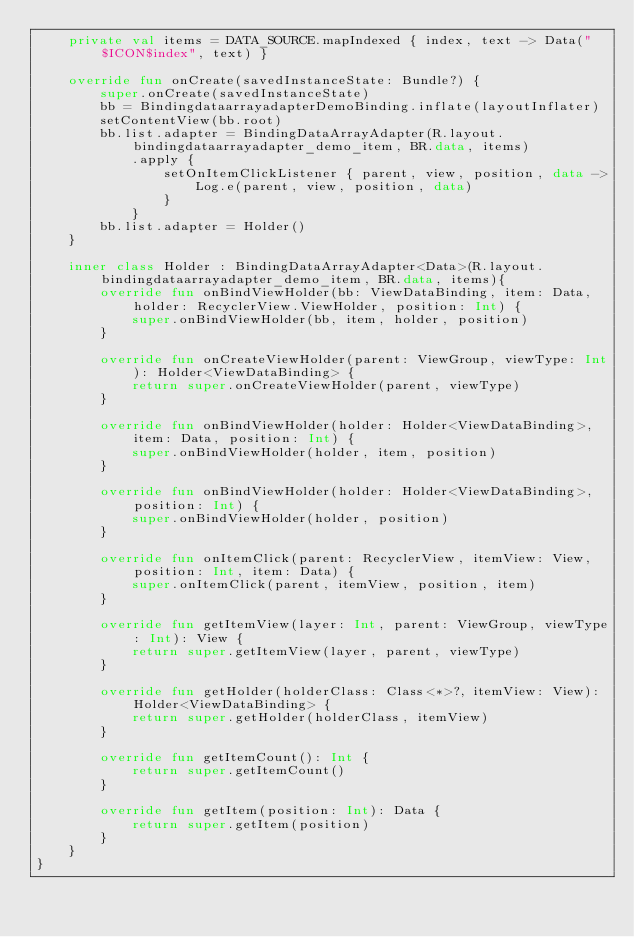<code> <loc_0><loc_0><loc_500><loc_500><_Kotlin_>    private val items = DATA_SOURCE.mapIndexed { index, text -> Data("$ICON$index", text) }

    override fun onCreate(savedInstanceState: Bundle?) {
        super.onCreate(savedInstanceState)
        bb = BindingdataarrayadapterDemoBinding.inflate(layoutInflater)
        setContentView(bb.root)
        bb.list.adapter = BindingDataArrayAdapter(R.layout.bindingdataarrayadapter_demo_item, BR.data, items)
            .apply {
                setOnItemClickListener { parent, view, position, data ->
                    Log.e(parent, view, position, data)
                }
            }
        bb.list.adapter = Holder()
    }

    inner class Holder : BindingDataArrayAdapter<Data>(R.layout.bindingdataarrayadapter_demo_item, BR.data, items){
        override fun onBindViewHolder(bb: ViewDataBinding, item: Data, holder: RecyclerView.ViewHolder, position: Int) {
            super.onBindViewHolder(bb, item, holder, position)
        }

        override fun onCreateViewHolder(parent: ViewGroup, viewType: Int): Holder<ViewDataBinding> {
            return super.onCreateViewHolder(parent, viewType)
        }

        override fun onBindViewHolder(holder: Holder<ViewDataBinding>, item: Data, position: Int) {
            super.onBindViewHolder(holder, item, position)
        }

        override fun onBindViewHolder(holder: Holder<ViewDataBinding>, position: Int) {
            super.onBindViewHolder(holder, position)
        }

        override fun onItemClick(parent: RecyclerView, itemView: View, position: Int, item: Data) {
            super.onItemClick(parent, itemView, position, item)
        }

        override fun getItemView(layer: Int, parent: ViewGroup, viewType: Int): View {
            return super.getItemView(layer, parent, viewType)
        }

        override fun getHolder(holderClass: Class<*>?, itemView: View): Holder<ViewDataBinding> {
            return super.getHolder(holderClass, itemView)
        }

        override fun getItemCount(): Int {
            return super.getItemCount()
        }

        override fun getItem(position: Int): Data {
            return super.getItem(position)
        }
    }
}
</code> 